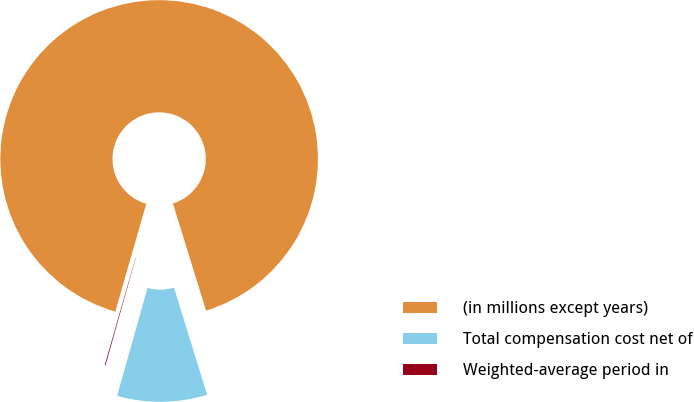Convert chart to OTSL. <chart><loc_0><loc_0><loc_500><loc_500><pie_chart><fcel>(in millions except years)<fcel>Total compensation cost net of<fcel>Weighted-average period in<nl><fcel>90.77%<fcel>9.15%<fcel>0.08%<nl></chart> 